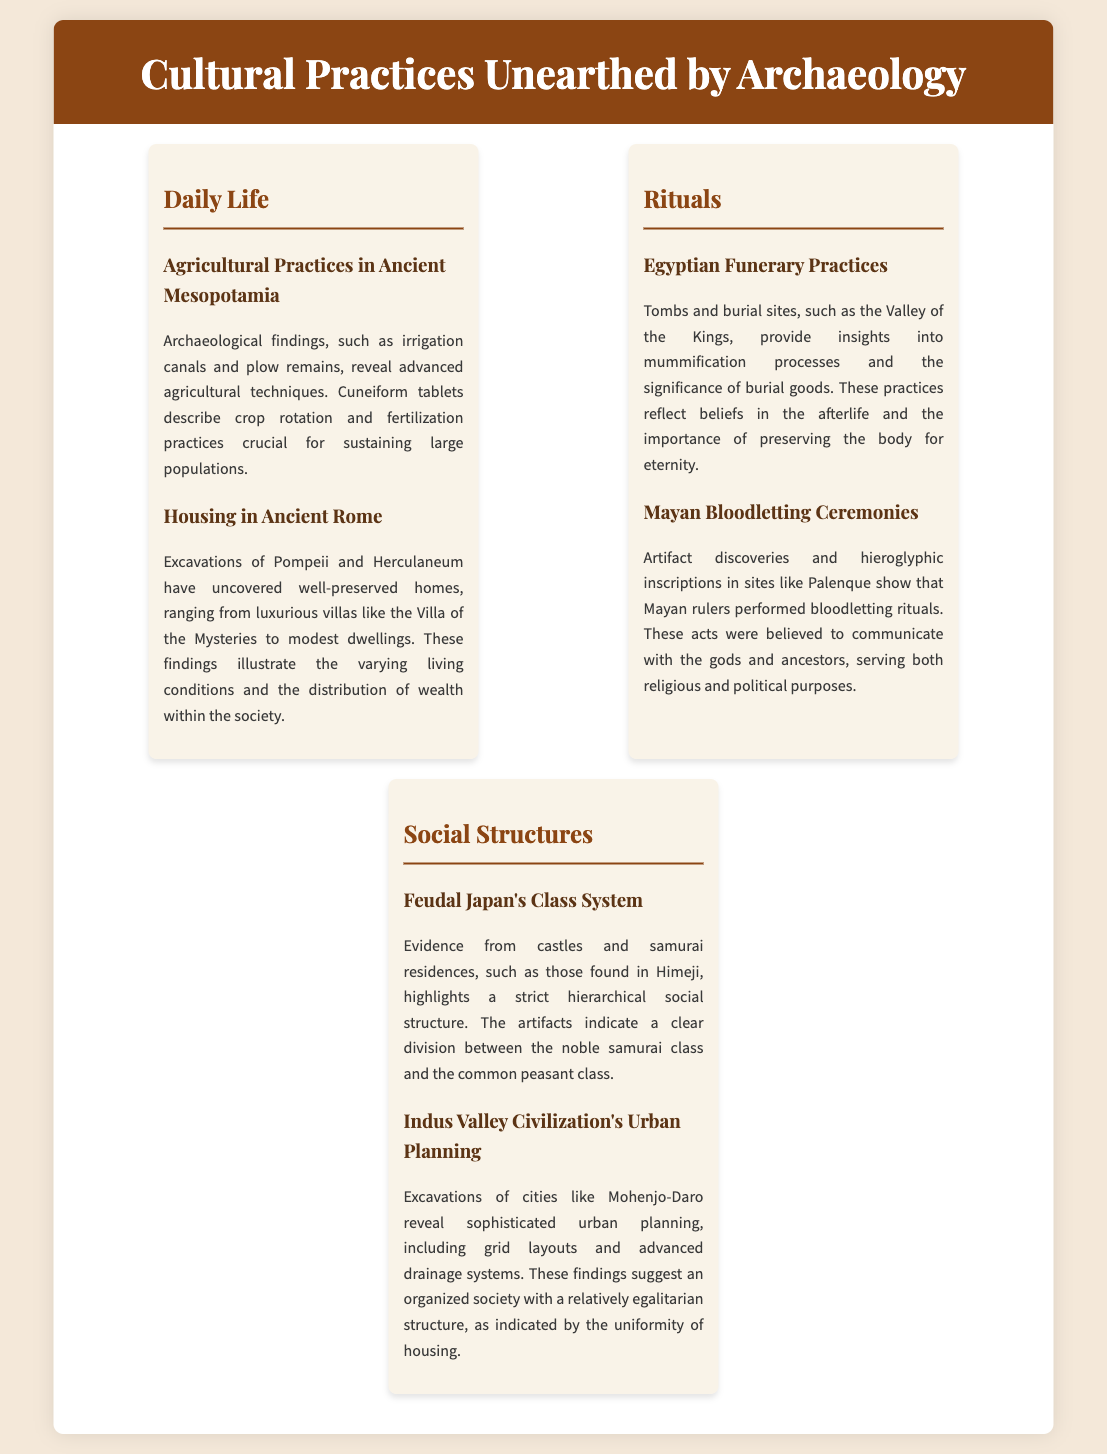what agricultural techniques are revealed in Mesopotamia? The practices include irrigation canals, plow remains, crop rotation, and fertilization techniques.
Answer: irrigation canals what burial site provides insights into Egyptian funerary practices? The significant site is the Valley of the Kings, where tombs reveal details about mummification and burial goods.
Answer: Valley of the Kings which civilization's urban planning is highlighted in the document? The Indus Valley Civilization features advanced urban planning with grid layouts and drainage systems.
Answer: Indus Valley Civilization what is the primary purpose of Mayan bloodletting ceremonies? These ceremonies were believed to communicate with the gods and ancestors, serving both religious and political purposes.
Answer: communicate with the gods how does the document categorize cultural practices? The document categorizes cultural practices into three sections: Daily Life, Rituals, and Social Structures.
Answer: three sections what evidence highlights the class system in Feudal Japan? Evidence includes artifacts from castles and samurai residences, indicating a clear division between classes.
Answer: artifacts from castles what type of houses are excavated from Pompeii? Excavations reveal both luxurious villas and modest dwellings, showcasing the range of living conditions.
Answer: luxurious villas and modest dwellings what is illustrated by the uniformity of housing in the Indus Valley? The uniformity suggests an organized society with a relatively egalitarian structure among its inhabitants.
Answer: relatively egalitarian structure what findings in Herculaneum illustrate wealth distribution in Rome? The excavated homes, varying from luxury villas to modest dwellings, illustrate wealth distribution within ancient Roman society.
Answer: varying living conditions 